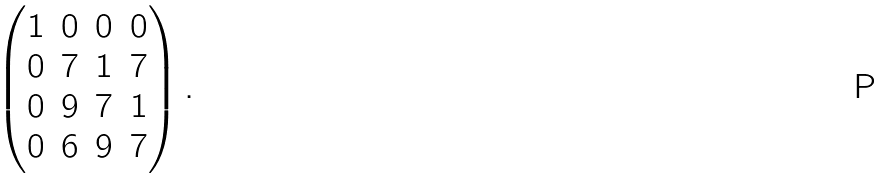Convert formula to latex. <formula><loc_0><loc_0><loc_500><loc_500>\begin{pmatrix} 1 & 0 & 0 & 0 \\ 0 & 7 & 1 & 7 \\ 0 & 9 & 7 & 1 \\ 0 & 6 & 9 & 7 \end{pmatrix} .</formula> 